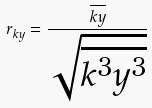Convert formula to latex. <formula><loc_0><loc_0><loc_500><loc_500>r _ { k y } = \frac { \overline { k y } } { \sqrt { \overline { k ^ { 3 } } \overline { y ^ { 3 } } } }</formula> 